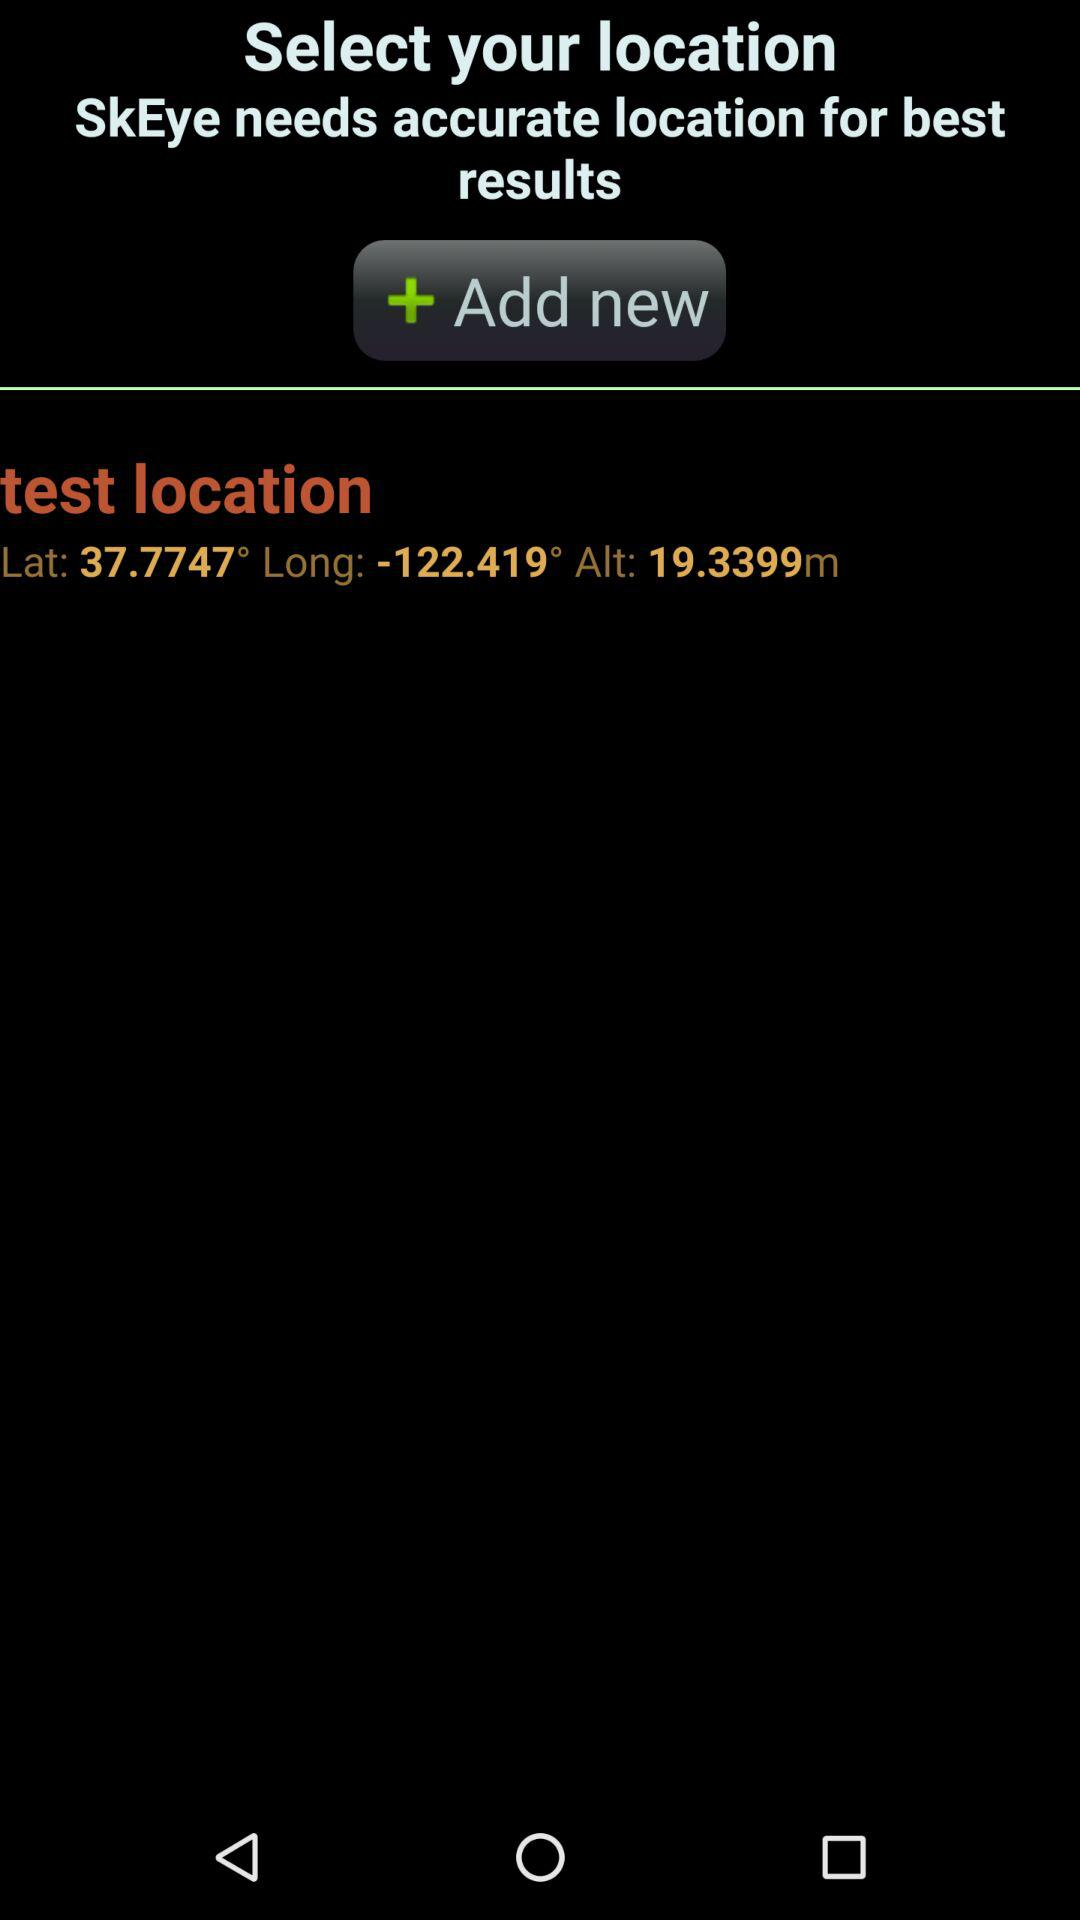What are the mentioned latitude and longitude? The mentioned latitude and longitude are 37.7747° and -122.419°, respectively. 